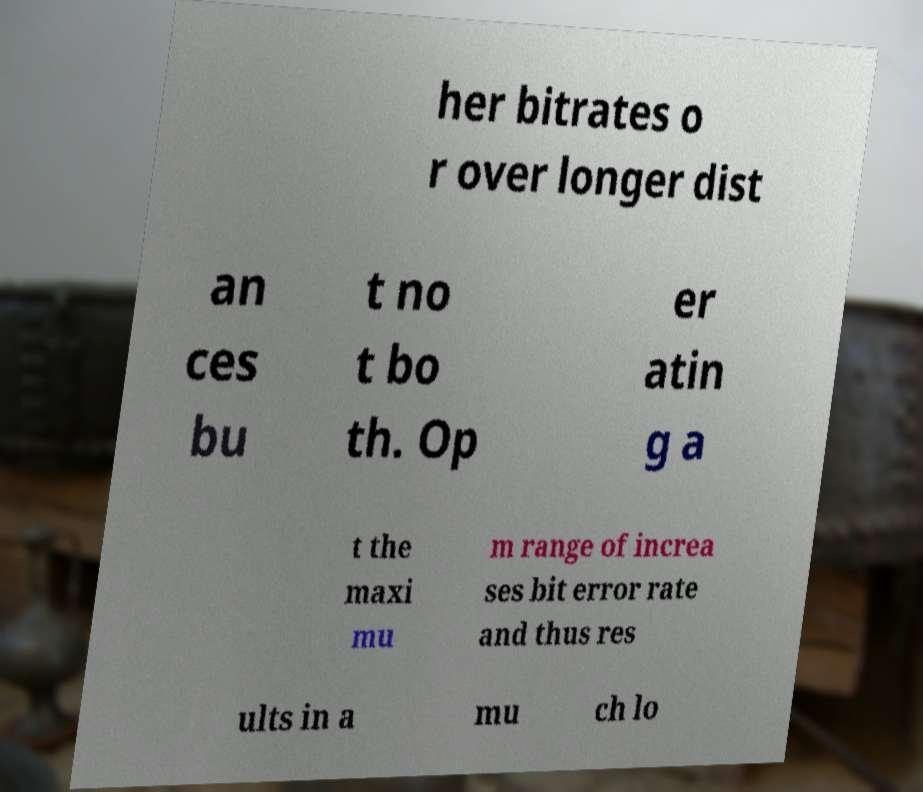I need the written content from this picture converted into text. Can you do that? her bitrates o r over longer dist an ces bu t no t bo th. Op er atin g a t the maxi mu m range of increa ses bit error rate and thus res ults in a mu ch lo 